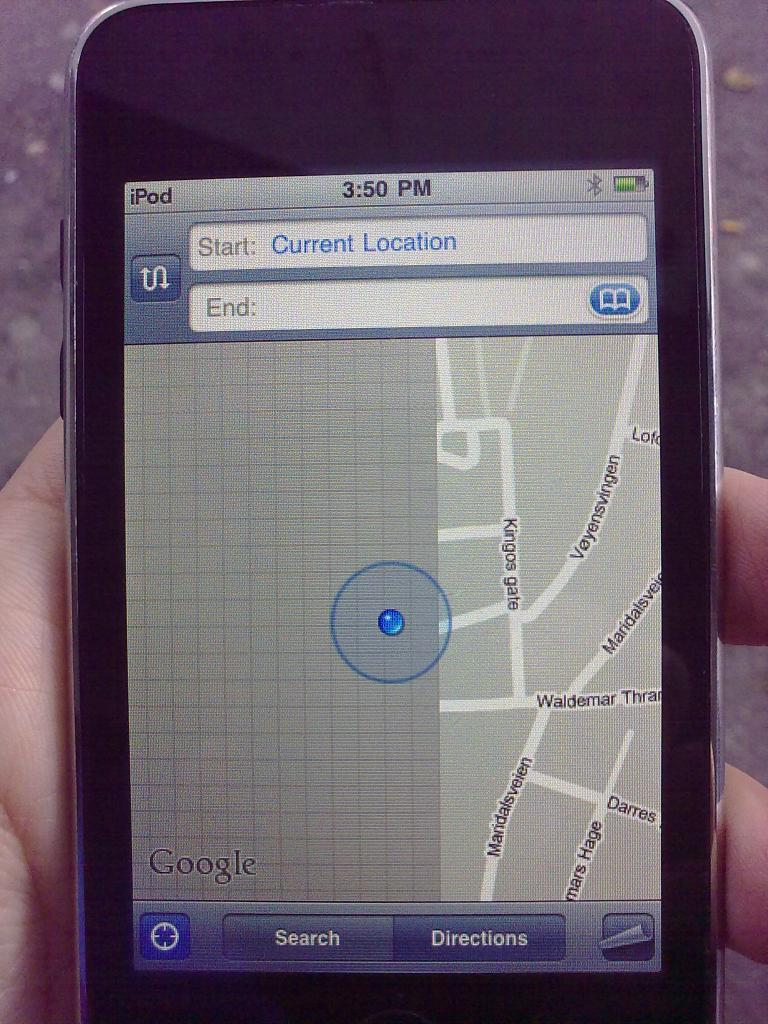<image>
Describe the image concisely. a cell phone shoing someones current location by kings gate 